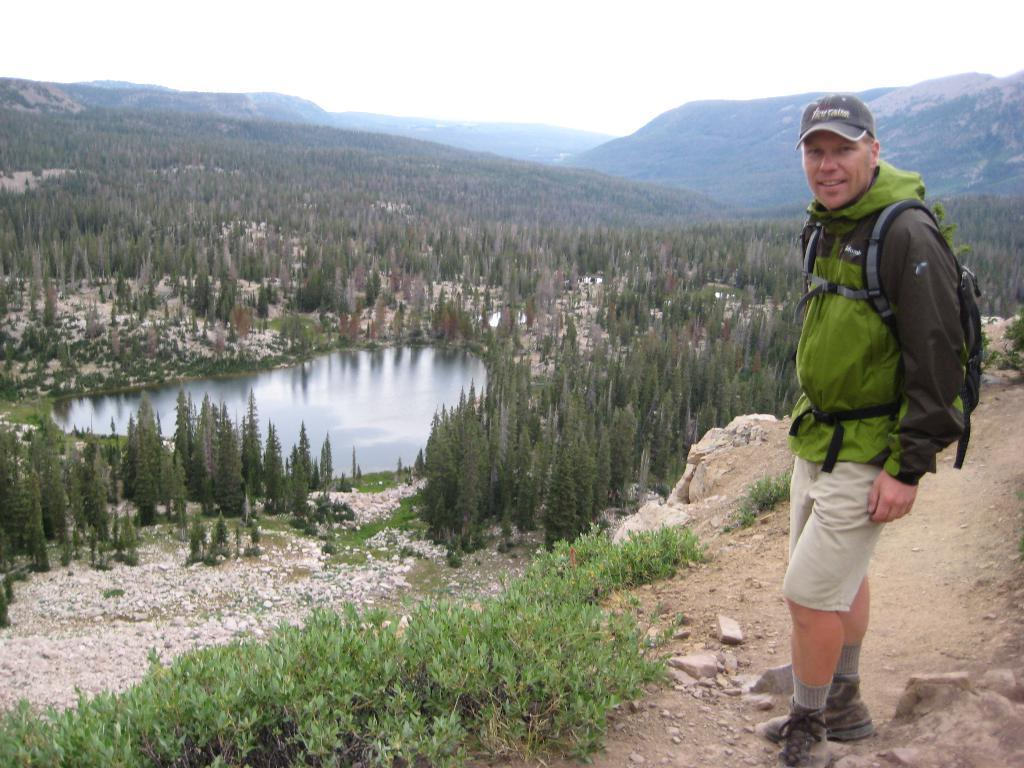What is the position of the person in the image? The person is on the right side of the image. What is the person holding or carrying in the image? The person is carrying a bag. What type of clothing is the person wearing in the image? The person is wearing a jacket. What can be seen in the background of the image? There are trees and a pool in the background of the image. What is the setting of the image? The image appears to be set in a hilly area. What type of sock is the person wearing on their left foot in the image? There is no information about the person's socks in the image, so we cannot determine the type of sock they are wearing. What is the person using to drink from the pool in the image? There is no straw or any indication of the person drinking from the pool in the image. 